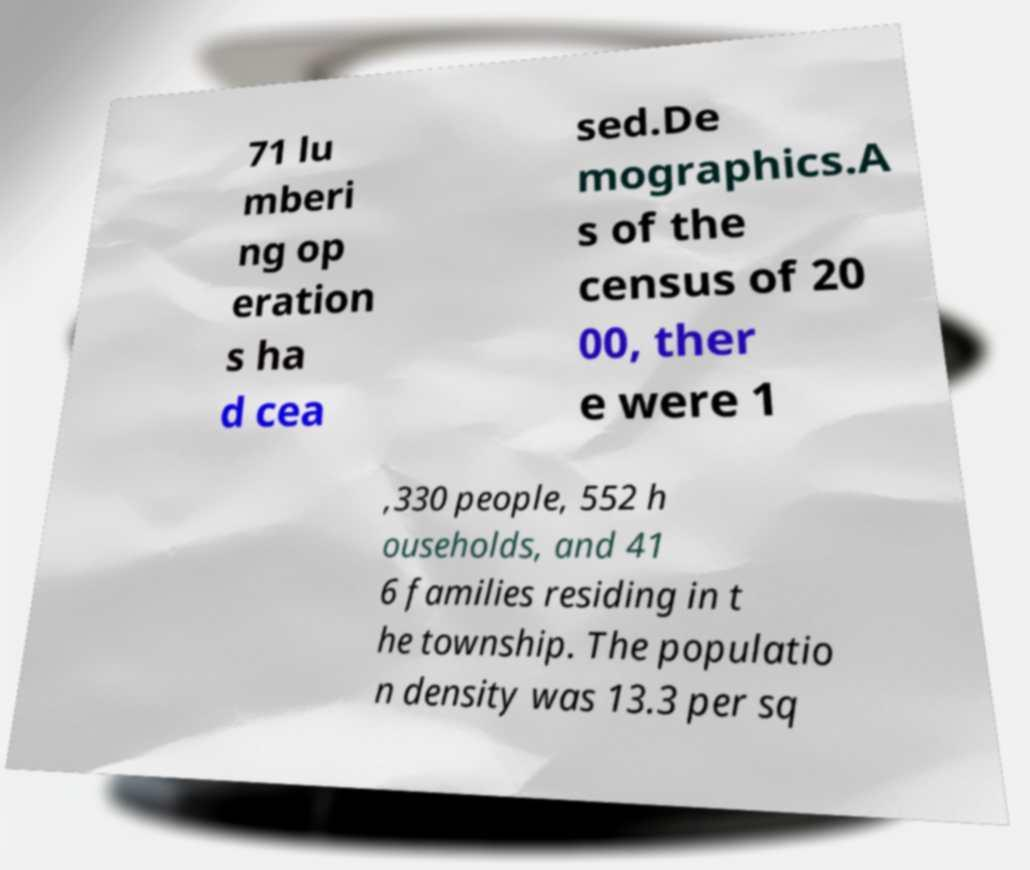Could you extract and type out the text from this image? 71 lu mberi ng op eration s ha d cea sed.De mographics.A s of the census of 20 00, ther e were 1 ,330 people, 552 h ouseholds, and 41 6 families residing in t he township. The populatio n density was 13.3 per sq 